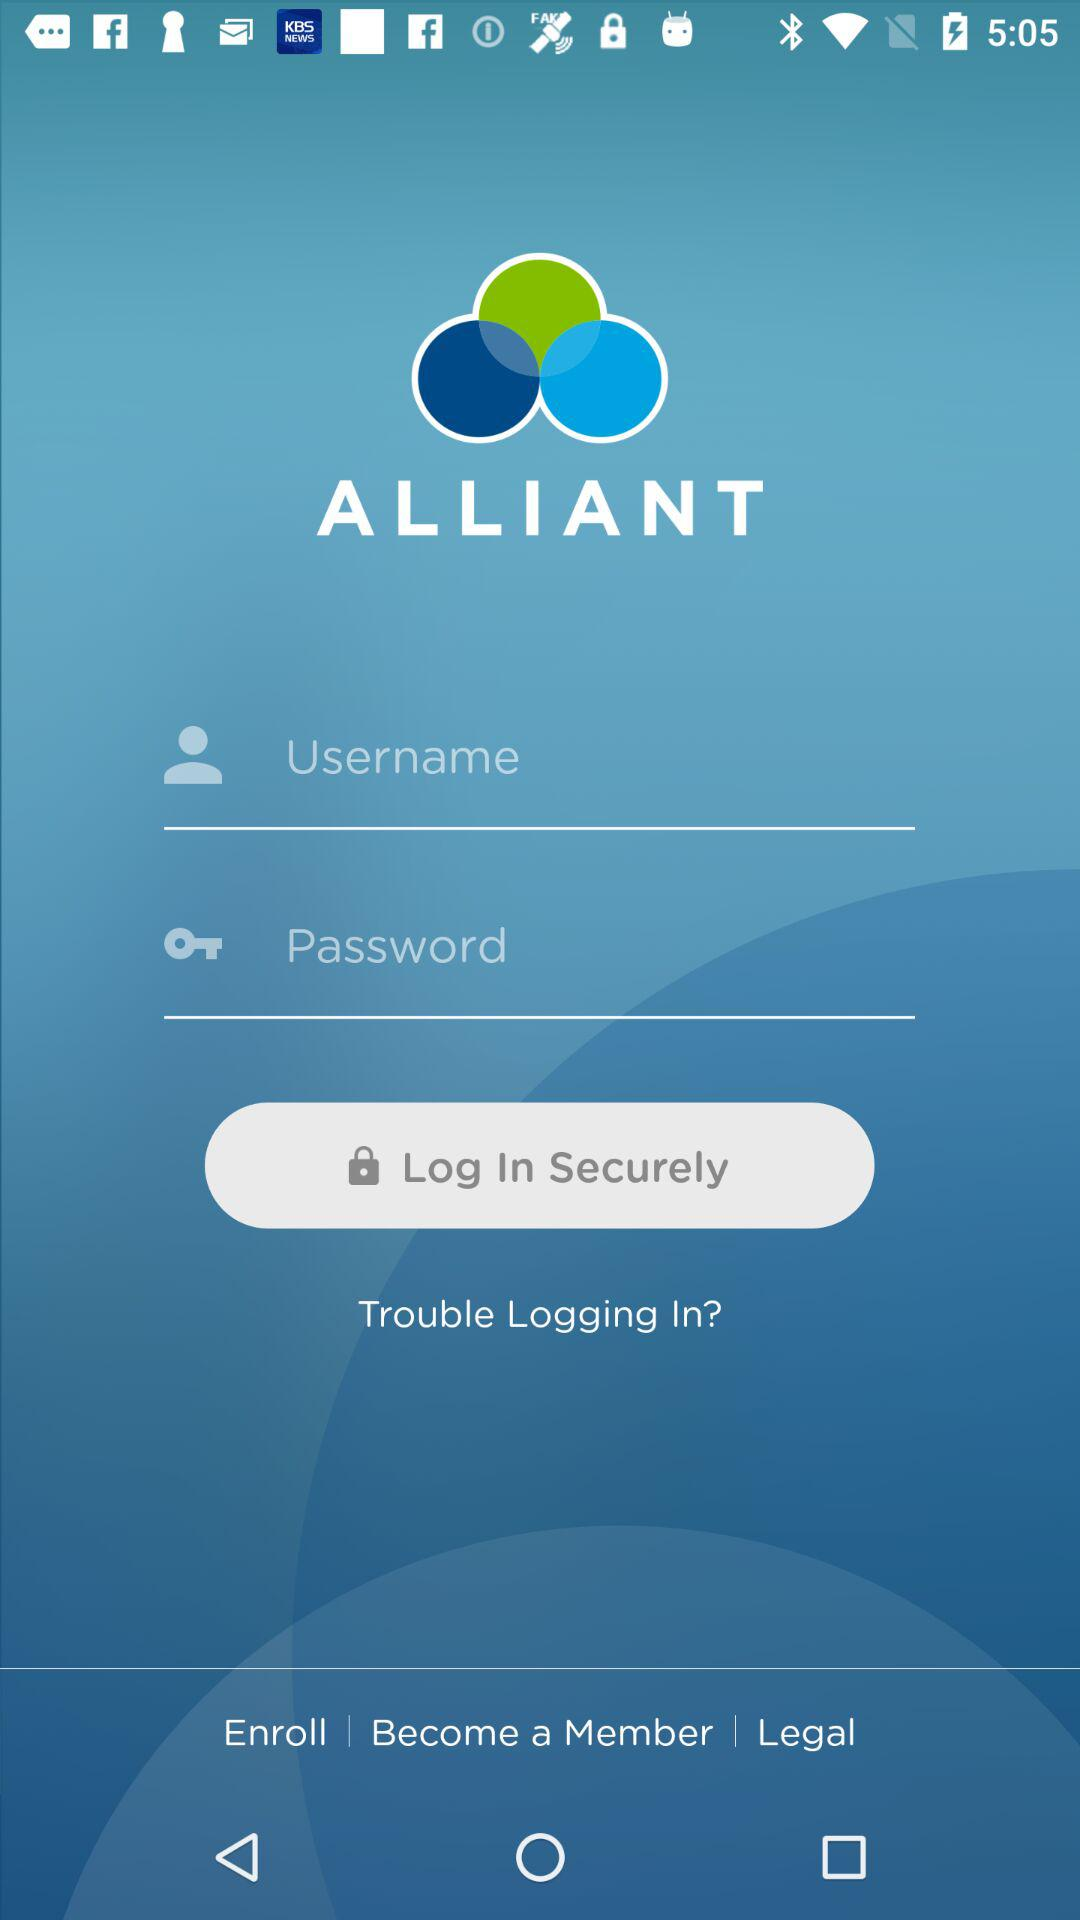How can we log in? You can log in with the username and password. 